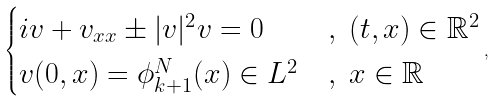Convert formula to latex. <formula><loc_0><loc_0><loc_500><loc_500>\begin{cases} i v + v _ { x x } \pm | v | ^ { 2 } v = 0 & , \ ( t , x ) \in \mathbb { R } ^ { 2 } \\ v ( 0 , x ) = \phi _ { k + 1 } ^ { N } ( x ) \in L ^ { 2 } & , \ x \in \mathbb { R } \\ \end{cases} ,</formula> 